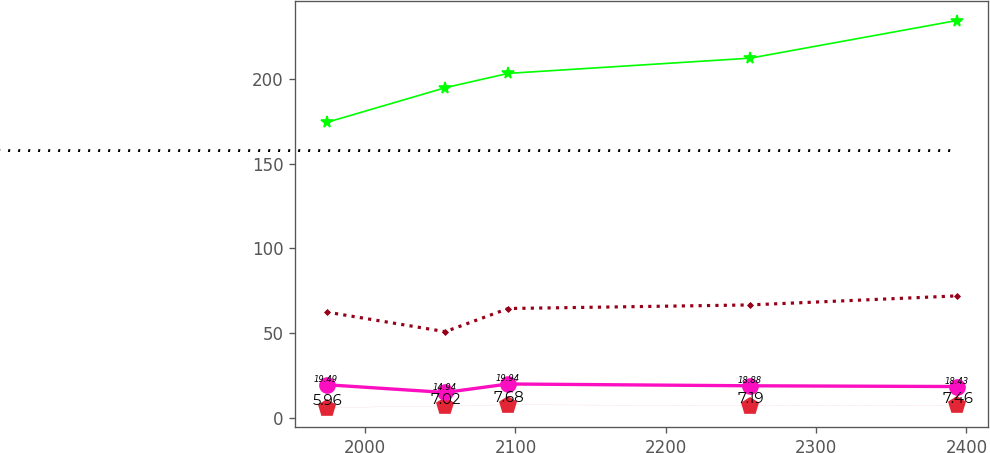<chart> <loc_0><loc_0><loc_500><loc_500><line_chart><ecel><fcel>Other Postretirement Benefit Plans Gross Payments .........................................................................................................................................................................................<fcel>Postemployment Benefit Plans<fcel>Defined Benefit Pension Plans<fcel>Medicare Subsidy Receipts<nl><fcel>1974.36<fcel>174.26<fcel>62.36<fcel>5.96<fcel>19.49<nl><fcel>2053.24<fcel>194.73<fcel>50.81<fcel>7.02<fcel>14.94<nl><fcel>2095.17<fcel>203.19<fcel>64.47<fcel>7.68<fcel>19.94<nl><fcel>2256.03<fcel>212.16<fcel>66.58<fcel>7.19<fcel>18.88<nl><fcel>2393.62<fcel>234.37<fcel>71.91<fcel>7.46<fcel>18.43<nl></chart> 